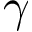<formula> <loc_0><loc_0><loc_500><loc_500>\gamma</formula> 